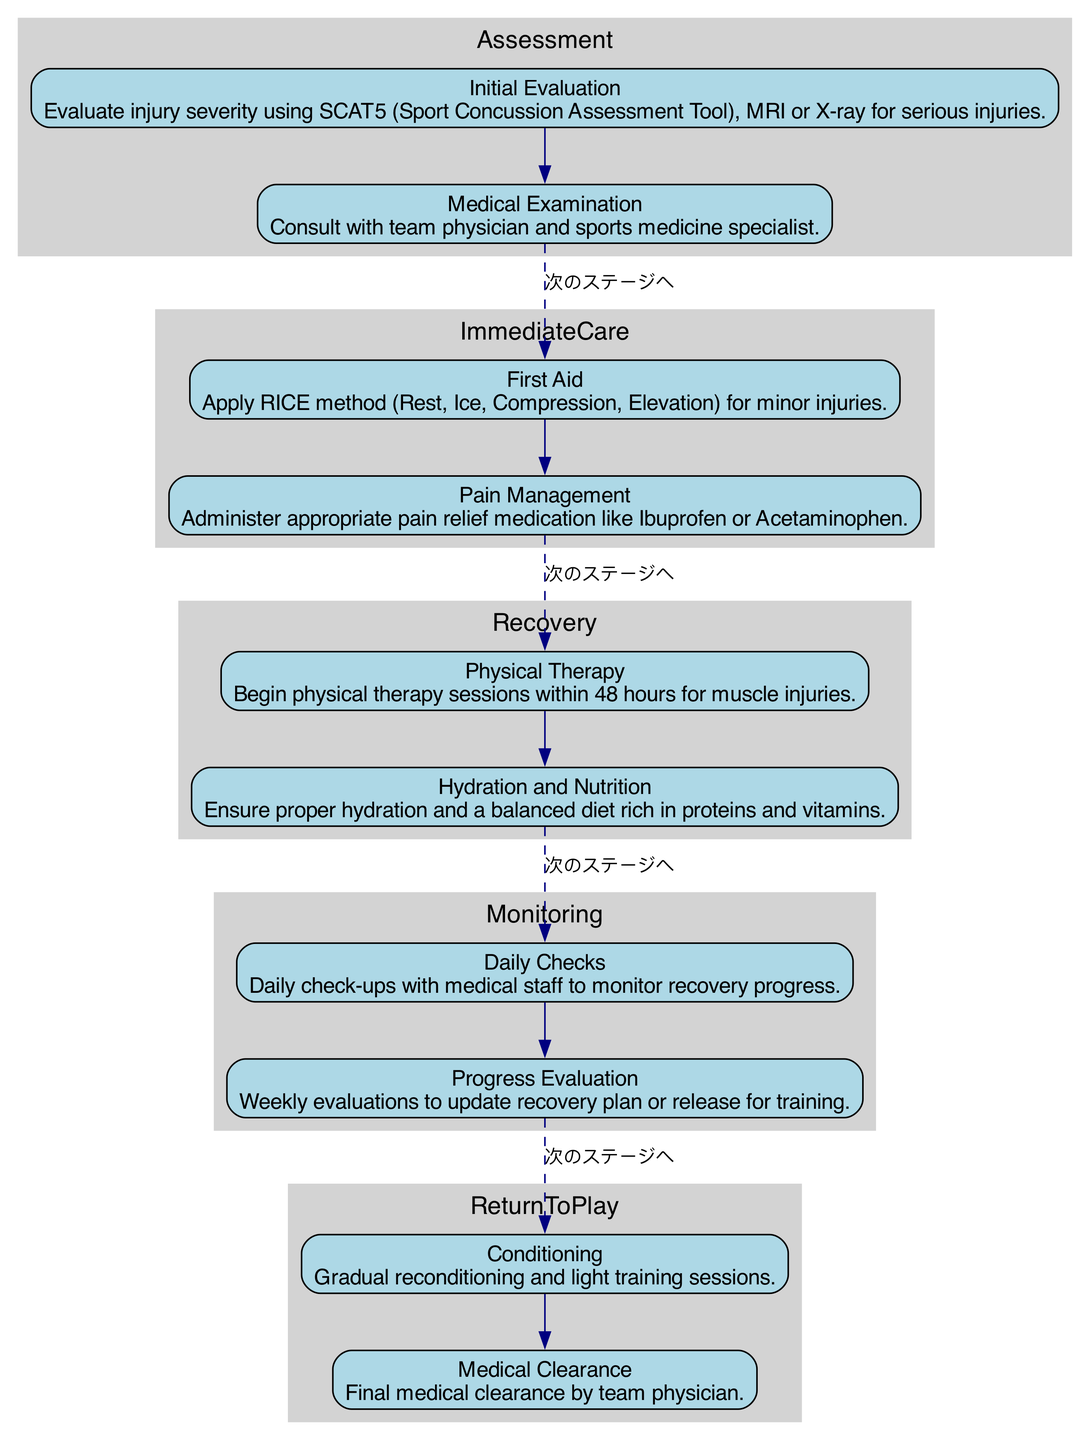What is the first stage of the Clinical Pathway? The first stage, as indicated in the diagram, is "Initial Evaluation." This stage is identified within the "Assessment" cluster and is listed first in the sequence.
Answer: Initial Evaluation How many stages are there in total in the Clinical Pathway? By counting the different clusters, we have five major stages: Assessment, Immediate Care, Recovery, Monitoring, and Return to Play. Therefore, the total number of stages is 5.
Answer: 5 What method is applied for minor injuries during Immediate Care? The diagram specifies the RICE method (Rest, Ice, Compression, Elevation) for minor injuries within the "First Aid" stage of Immediate Care.
Answer: RICE method In which stage does Physical Therapy occur? Physical Therapy takes place in the "Recovery" stage, as specified in the diagram. This is the second cluster where this stage is prominently displayed.
Answer: Recovery What is the relationship between Pain Management and Daily Checks? The relationship is that both Pain Management and Daily Checks are part of different clusters (Immediate Care and Monitoring, respectively), but Daily Checks follow after the Immediate Care stage, indicating a progression in the management of injuries outlined in the Clinical Pathway.
Answer: Next stage Which medication is mentioned for pain relief? The medication for pain relief mentioned in the diagram is Ibuprofen or Acetaminophen, as stated in the details of the "Pain Management" stage within Immediate Care.
Answer: Ibuprofen or Acetaminophen What step follows after Medical Clearance? According to the diagram, nothing follows after Medical Clearance as it is the final step in the "Return to Play" stage, indicating the conclusion of the Clinical Pathway process.
Answer: None How often are Progress Evaluations conducted? Progress Evaluations are conducted weekly, as specified under the "Monitoring" cluster of the Clinical Pathway.
Answer: Weekly What is the purpose of the Daily Checks? The Daily Checks are intended for monitoring recovery progress, as detailed in the Monitoring stage of the Clinical Pathway.
Answer: Monitor recovery progress 